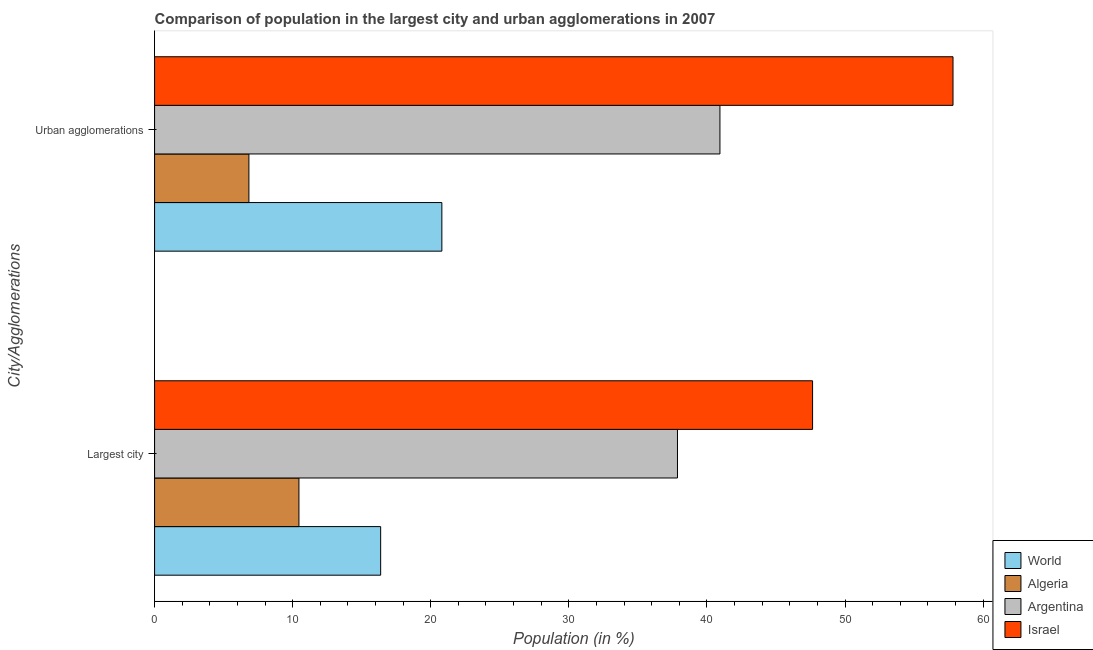How many different coloured bars are there?
Provide a short and direct response. 4. How many groups of bars are there?
Give a very brief answer. 2. Are the number of bars per tick equal to the number of legend labels?
Your answer should be compact. Yes. Are the number of bars on each tick of the Y-axis equal?
Your response must be concise. Yes. What is the label of the 2nd group of bars from the top?
Your response must be concise. Largest city. What is the population in the largest city in World?
Keep it short and to the point. 16.37. Across all countries, what is the maximum population in urban agglomerations?
Ensure brevity in your answer.  57.82. Across all countries, what is the minimum population in urban agglomerations?
Give a very brief answer. 6.83. In which country was the population in urban agglomerations maximum?
Offer a very short reply. Israel. In which country was the population in the largest city minimum?
Give a very brief answer. Algeria. What is the total population in urban agglomerations in the graph?
Your answer should be very brief. 126.4. What is the difference between the population in the largest city in Algeria and that in World?
Provide a short and direct response. -5.92. What is the difference between the population in the largest city in Argentina and the population in urban agglomerations in Israel?
Ensure brevity in your answer.  -19.95. What is the average population in urban agglomerations per country?
Keep it short and to the point. 31.6. What is the difference between the population in urban agglomerations and population in the largest city in World?
Make the answer very short. 4.43. What is the ratio of the population in urban agglomerations in Algeria to that in Argentina?
Ensure brevity in your answer.  0.17. In how many countries, is the population in urban agglomerations greater than the average population in urban agglomerations taken over all countries?
Ensure brevity in your answer.  2. What does the 4th bar from the bottom in Largest city represents?
Your answer should be compact. Israel. How many bars are there?
Ensure brevity in your answer.  8. Are the values on the major ticks of X-axis written in scientific E-notation?
Give a very brief answer. No. What is the title of the graph?
Offer a very short reply. Comparison of population in the largest city and urban agglomerations in 2007. Does "Cuba" appear as one of the legend labels in the graph?
Keep it short and to the point. No. What is the label or title of the X-axis?
Ensure brevity in your answer.  Population (in %). What is the label or title of the Y-axis?
Ensure brevity in your answer.  City/Agglomerations. What is the Population (in %) of World in Largest city?
Offer a terse response. 16.37. What is the Population (in %) of Algeria in Largest city?
Offer a terse response. 10.45. What is the Population (in %) in Argentina in Largest city?
Offer a very short reply. 37.87. What is the Population (in %) in Israel in Largest city?
Offer a terse response. 47.65. What is the Population (in %) in World in Urban agglomerations?
Provide a succinct answer. 20.8. What is the Population (in %) of Algeria in Urban agglomerations?
Your answer should be very brief. 6.83. What is the Population (in %) of Argentina in Urban agglomerations?
Your answer should be compact. 40.94. What is the Population (in %) of Israel in Urban agglomerations?
Offer a terse response. 57.82. Across all City/Agglomerations, what is the maximum Population (in %) in World?
Ensure brevity in your answer.  20.8. Across all City/Agglomerations, what is the maximum Population (in %) of Algeria?
Give a very brief answer. 10.45. Across all City/Agglomerations, what is the maximum Population (in %) of Argentina?
Make the answer very short. 40.94. Across all City/Agglomerations, what is the maximum Population (in %) in Israel?
Keep it short and to the point. 57.82. Across all City/Agglomerations, what is the minimum Population (in %) in World?
Keep it short and to the point. 16.37. Across all City/Agglomerations, what is the minimum Population (in %) in Algeria?
Keep it short and to the point. 6.83. Across all City/Agglomerations, what is the minimum Population (in %) in Argentina?
Keep it short and to the point. 37.87. Across all City/Agglomerations, what is the minimum Population (in %) of Israel?
Your response must be concise. 47.65. What is the total Population (in %) in World in the graph?
Offer a very short reply. 37.18. What is the total Population (in %) of Algeria in the graph?
Provide a short and direct response. 17.29. What is the total Population (in %) in Argentina in the graph?
Your answer should be very brief. 78.81. What is the total Population (in %) of Israel in the graph?
Your answer should be very brief. 105.47. What is the difference between the Population (in %) of World in Largest city and that in Urban agglomerations?
Your answer should be very brief. -4.43. What is the difference between the Population (in %) of Algeria in Largest city and that in Urban agglomerations?
Make the answer very short. 3.62. What is the difference between the Population (in %) in Argentina in Largest city and that in Urban agglomerations?
Provide a succinct answer. -3.08. What is the difference between the Population (in %) of Israel in Largest city and that in Urban agglomerations?
Your response must be concise. -10.17. What is the difference between the Population (in %) in World in Largest city and the Population (in %) in Algeria in Urban agglomerations?
Offer a very short reply. 9.54. What is the difference between the Population (in %) in World in Largest city and the Population (in %) in Argentina in Urban agglomerations?
Provide a succinct answer. -24.57. What is the difference between the Population (in %) of World in Largest city and the Population (in %) of Israel in Urban agglomerations?
Keep it short and to the point. -41.45. What is the difference between the Population (in %) of Algeria in Largest city and the Population (in %) of Argentina in Urban agglomerations?
Your answer should be compact. -30.49. What is the difference between the Population (in %) of Algeria in Largest city and the Population (in %) of Israel in Urban agglomerations?
Provide a short and direct response. -47.37. What is the difference between the Population (in %) of Argentina in Largest city and the Population (in %) of Israel in Urban agglomerations?
Offer a very short reply. -19.95. What is the average Population (in %) in World per City/Agglomerations?
Your answer should be compact. 18.59. What is the average Population (in %) of Algeria per City/Agglomerations?
Your answer should be very brief. 8.64. What is the average Population (in %) of Argentina per City/Agglomerations?
Make the answer very short. 39.4. What is the average Population (in %) in Israel per City/Agglomerations?
Offer a terse response. 52.73. What is the difference between the Population (in %) of World and Population (in %) of Algeria in Largest city?
Your answer should be compact. 5.92. What is the difference between the Population (in %) in World and Population (in %) in Argentina in Largest city?
Provide a succinct answer. -21.49. What is the difference between the Population (in %) in World and Population (in %) in Israel in Largest city?
Offer a terse response. -31.28. What is the difference between the Population (in %) in Algeria and Population (in %) in Argentina in Largest city?
Your answer should be compact. -27.41. What is the difference between the Population (in %) of Algeria and Population (in %) of Israel in Largest city?
Your answer should be compact. -37.2. What is the difference between the Population (in %) in Argentina and Population (in %) in Israel in Largest city?
Give a very brief answer. -9.78. What is the difference between the Population (in %) in World and Population (in %) in Algeria in Urban agglomerations?
Ensure brevity in your answer.  13.97. What is the difference between the Population (in %) of World and Population (in %) of Argentina in Urban agglomerations?
Keep it short and to the point. -20.14. What is the difference between the Population (in %) of World and Population (in %) of Israel in Urban agglomerations?
Your answer should be very brief. -37.02. What is the difference between the Population (in %) in Algeria and Population (in %) in Argentina in Urban agglomerations?
Ensure brevity in your answer.  -34.11. What is the difference between the Population (in %) in Algeria and Population (in %) in Israel in Urban agglomerations?
Your answer should be very brief. -50.99. What is the difference between the Population (in %) in Argentina and Population (in %) in Israel in Urban agglomerations?
Your response must be concise. -16.88. What is the ratio of the Population (in %) in World in Largest city to that in Urban agglomerations?
Offer a terse response. 0.79. What is the ratio of the Population (in %) in Algeria in Largest city to that in Urban agglomerations?
Give a very brief answer. 1.53. What is the ratio of the Population (in %) in Argentina in Largest city to that in Urban agglomerations?
Provide a short and direct response. 0.92. What is the ratio of the Population (in %) of Israel in Largest city to that in Urban agglomerations?
Your response must be concise. 0.82. What is the difference between the highest and the second highest Population (in %) in World?
Your response must be concise. 4.43. What is the difference between the highest and the second highest Population (in %) of Algeria?
Provide a succinct answer. 3.62. What is the difference between the highest and the second highest Population (in %) of Argentina?
Your answer should be compact. 3.08. What is the difference between the highest and the second highest Population (in %) of Israel?
Keep it short and to the point. 10.17. What is the difference between the highest and the lowest Population (in %) of World?
Make the answer very short. 4.43. What is the difference between the highest and the lowest Population (in %) in Algeria?
Provide a succinct answer. 3.62. What is the difference between the highest and the lowest Population (in %) in Argentina?
Your answer should be compact. 3.08. What is the difference between the highest and the lowest Population (in %) in Israel?
Provide a short and direct response. 10.17. 